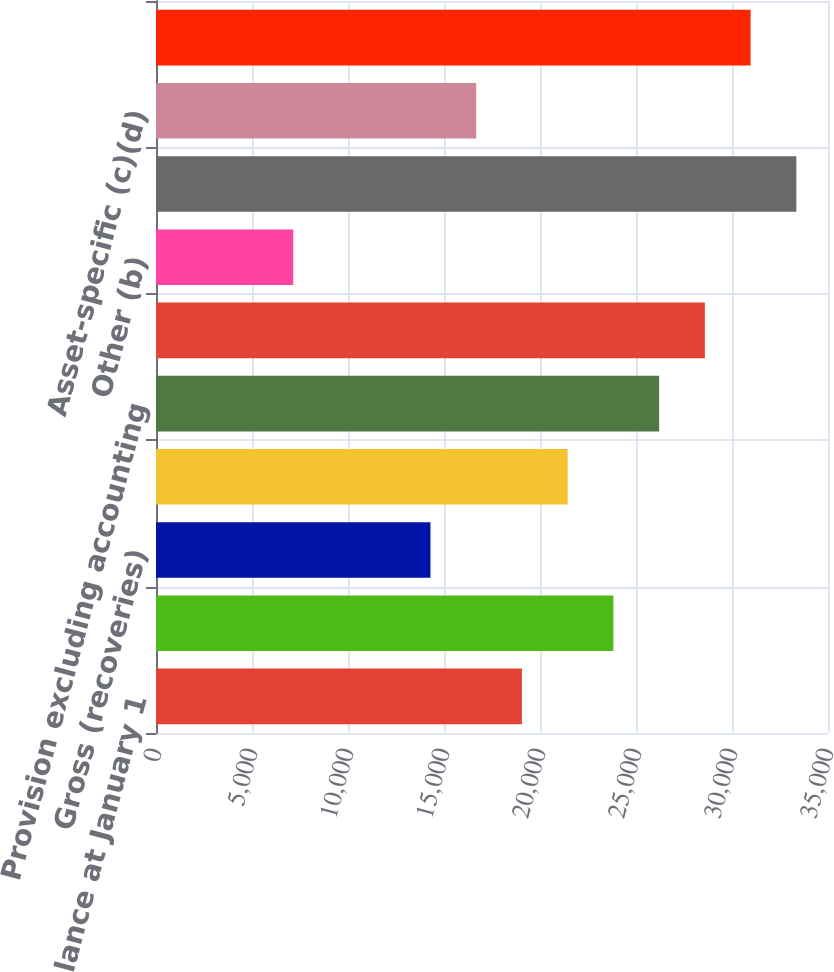Convert chart. <chart><loc_0><loc_0><loc_500><loc_500><bar_chart><fcel>Beginning balance at January 1<fcel>Gross charge-offs<fcel>Gross (recoveries)<fcel>Net charge-offs<fcel>Provision excluding accounting<fcel>Total provision for loan<fcel>Other (b)<fcel>Ending balance at December 31<fcel>Asset-specific (c)(d)<fcel>Formula-based<nl><fcel>19058.8<fcel>23823<fcel>14294.5<fcel>21440.9<fcel>26205.2<fcel>28587.3<fcel>7148.12<fcel>33351.6<fcel>16676.6<fcel>30969.4<nl></chart> 